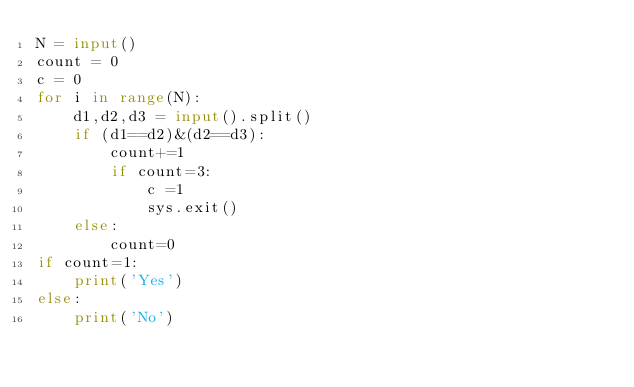Convert code to text. <code><loc_0><loc_0><loc_500><loc_500><_Python_>N = input()
count = 0
c = 0
for i in range(N):
    d1,d2,d3 = input().split()
    if (d1==d2)&(d2==d3):
        count+=1
        if count=3:
            c =1
            sys.exit()
    else:
        count=0
if count=1:
    print('Yes')
else:
    print('No')</code> 